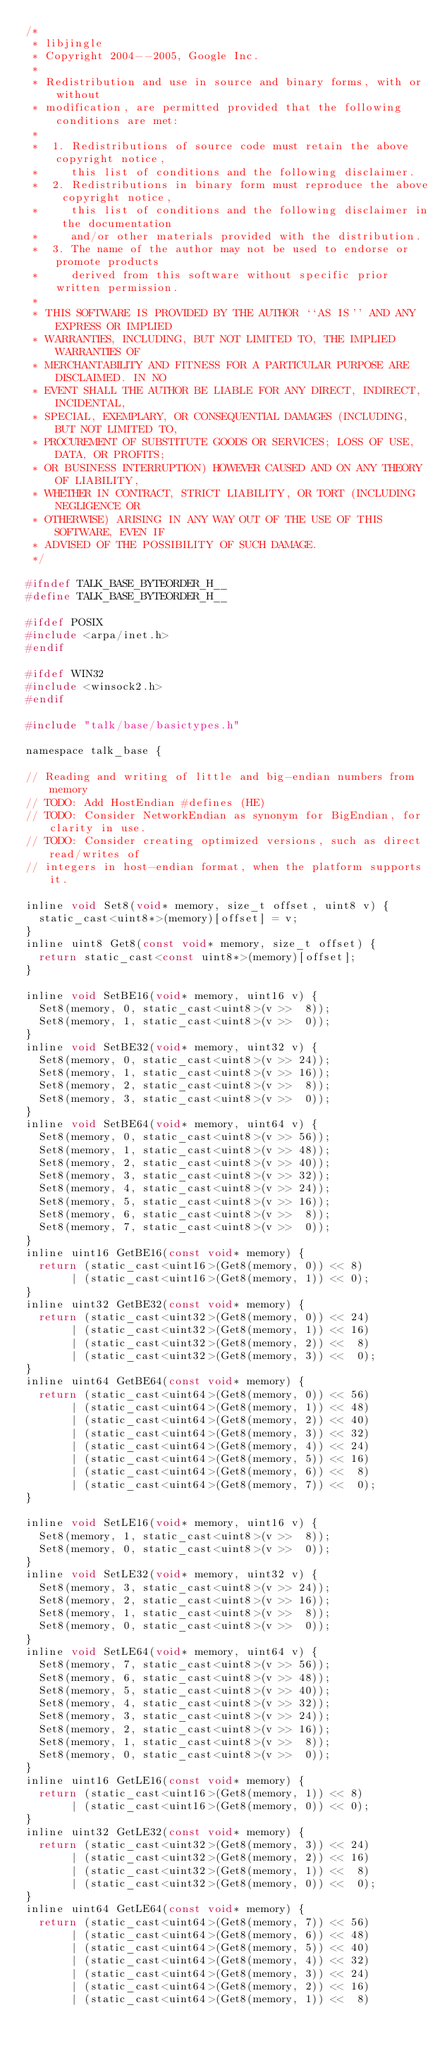<code> <loc_0><loc_0><loc_500><loc_500><_C_>/*
 * libjingle
 * Copyright 2004--2005, Google Inc.
 *
 * Redistribution and use in source and binary forms, with or without 
 * modification, are permitted provided that the following conditions are met:
 *
 *  1. Redistributions of source code must retain the above copyright notice, 
 *     this list of conditions and the following disclaimer.
 *  2. Redistributions in binary form must reproduce the above copyright notice,
 *     this list of conditions and the following disclaimer in the documentation
 *     and/or other materials provided with the distribution.
 *  3. The name of the author may not be used to endorse or promote products 
 *     derived from this software without specific prior written permission.
 *
 * THIS SOFTWARE IS PROVIDED BY THE AUTHOR ``AS IS'' AND ANY EXPRESS OR IMPLIED
 * WARRANTIES, INCLUDING, BUT NOT LIMITED TO, THE IMPLIED WARRANTIES OF 
 * MERCHANTABILITY AND FITNESS FOR A PARTICULAR PURPOSE ARE DISCLAIMED. IN NO
 * EVENT SHALL THE AUTHOR BE LIABLE FOR ANY DIRECT, INDIRECT, INCIDENTAL, 
 * SPECIAL, EXEMPLARY, OR CONSEQUENTIAL DAMAGES (INCLUDING, BUT NOT LIMITED TO,
 * PROCUREMENT OF SUBSTITUTE GOODS OR SERVICES; LOSS OF USE, DATA, OR PROFITS;
 * OR BUSINESS INTERRUPTION) HOWEVER CAUSED AND ON ANY THEORY OF LIABILITY,
 * WHETHER IN CONTRACT, STRICT LIABILITY, OR TORT (INCLUDING NEGLIGENCE OR 
 * OTHERWISE) ARISING IN ANY WAY OUT OF THE USE OF THIS SOFTWARE, EVEN IF 
 * ADVISED OF THE POSSIBILITY OF SUCH DAMAGE.
 */

#ifndef TALK_BASE_BYTEORDER_H__
#define TALK_BASE_BYTEORDER_H__

#ifdef POSIX
#include <arpa/inet.h>
#endif

#ifdef WIN32
#include <winsock2.h>
#endif

#include "talk/base/basictypes.h"

namespace talk_base {

// Reading and writing of little and big-endian numbers from memory
// TODO: Add HostEndian #defines (HE)
// TODO: Consider NetworkEndian as synonym for BigEndian, for clarity in use.
// TODO: Consider creating optimized versions, such as direct read/writes of
// integers in host-endian format, when the platform supports it.

inline void Set8(void* memory, size_t offset, uint8 v) {
  static_cast<uint8*>(memory)[offset] = v;
}
inline uint8 Get8(const void* memory, size_t offset) {
  return static_cast<const uint8*>(memory)[offset];
}

inline void SetBE16(void* memory, uint16 v) {
  Set8(memory, 0, static_cast<uint8>(v >>  8));
  Set8(memory, 1, static_cast<uint8>(v >>  0));
}
inline void SetBE32(void* memory, uint32 v) {
  Set8(memory, 0, static_cast<uint8>(v >> 24));
  Set8(memory, 1, static_cast<uint8>(v >> 16));
  Set8(memory, 2, static_cast<uint8>(v >>  8));
  Set8(memory, 3, static_cast<uint8>(v >>  0));
}
inline void SetBE64(void* memory, uint64 v) {
  Set8(memory, 0, static_cast<uint8>(v >> 56));
  Set8(memory, 1, static_cast<uint8>(v >> 48));
  Set8(memory, 2, static_cast<uint8>(v >> 40));
  Set8(memory, 3, static_cast<uint8>(v >> 32));
  Set8(memory, 4, static_cast<uint8>(v >> 24));
  Set8(memory, 5, static_cast<uint8>(v >> 16));
  Set8(memory, 6, static_cast<uint8>(v >>  8));
  Set8(memory, 7, static_cast<uint8>(v >>  0));
}
inline uint16 GetBE16(const void* memory) {
  return (static_cast<uint16>(Get8(memory, 0)) << 8)
       | (static_cast<uint16>(Get8(memory, 1)) << 0);
}
inline uint32 GetBE32(const void* memory) {
  return (static_cast<uint32>(Get8(memory, 0)) << 24)
       | (static_cast<uint32>(Get8(memory, 1)) << 16)
       | (static_cast<uint32>(Get8(memory, 2)) <<  8)
       | (static_cast<uint32>(Get8(memory, 3)) <<  0);
}
inline uint64 GetBE64(const void* memory) {
  return (static_cast<uint64>(Get8(memory, 0)) << 56)
       | (static_cast<uint64>(Get8(memory, 1)) << 48)
       | (static_cast<uint64>(Get8(memory, 2)) << 40)
       | (static_cast<uint64>(Get8(memory, 3)) << 32)
       | (static_cast<uint64>(Get8(memory, 4)) << 24)
       | (static_cast<uint64>(Get8(memory, 5)) << 16)
       | (static_cast<uint64>(Get8(memory, 6)) <<  8)
       | (static_cast<uint64>(Get8(memory, 7)) <<  0);
}

inline void SetLE16(void* memory, uint16 v) {
  Set8(memory, 1, static_cast<uint8>(v >>  8));
  Set8(memory, 0, static_cast<uint8>(v >>  0));
}
inline void SetLE32(void* memory, uint32 v) {
  Set8(memory, 3, static_cast<uint8>(v >> 24));
  Set8(memory, 2, static_cast<uint8>(v >> 16));
  Set8(memory, 1, static_cast<uint8>(v >>  8));
  Set8(memory, 0, static_cast<uint8>(v >>  0));
}
inline void SetLE64(void* memory, uint64 v) {
  Set8(memory, 7, static_cast<uint8>(v >> 56));
  Set8(memory, 6, static_cast<uint8>(v >> 48));
  Set8(memory, 5, static_cast<uint8>(v >> 40));
  Set8(memory, 4, static_cast<uint8>(v >> 32));
  Set8(memory, 3, static_cast<uint8>(v >> 24));
  Set8(memory, 2, static_cast<uint8>(v >> 16));
  Set8(memory, 1, static_cast<uint8>(v >>  8));
  Set8(memory, 0, static_cast<uint8>(v >>  0));
}
inline uint16 GetLE16(const void* memory) {
  return (static_cast<uint16>(Get8(memory, 1)) << 8)
       | (static_cast<uint16>(Get8(memory, 0)) << 0);
}
inline uint32 GetLE32(const void* memory) {
  return (static_cast<uint32>(Get8(memory, 3)) << 24)
       | (static_cast<uint32>(Get8(memory, 2)) << 16)
       | (static_cast<uint32>(Get8(memory, 1)) <<  8)
       | (static_cast<uint32>(Get8(memory, 0)) <<  0);
}
inline uint64 GetLE64(const void* memory) {
  return (static_cast<uint64>(Get8(memory, 7)) << 56)
       | (static_cast<uint64>(Get8(memory, 6)) << 48)
       | (static_cast<uint64>(Get8(memory, 5)) << 40)
       | (static_cast<uint64>(Get8(memory, 4)) << 32)
       | (static_cast<uint64>(Get8(memory, 3)) << 24)
       | (static_cast<uint64>(Get8(memory, 2)) << 16)
       | (static_cast<uint64>(Get8(memory, 1)) <<  8)</code> 